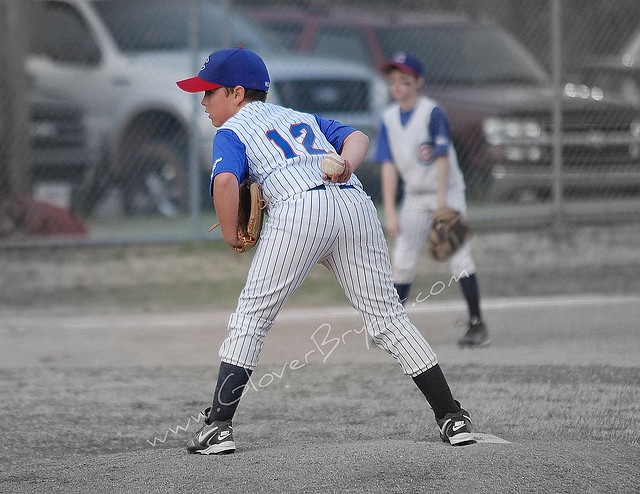Describe the objects in this image and their specific colors. I can see people in gray, lightgray, darkgray, and black tones, car in gray and darkgray tones, car in gray, black, and darkblue tones, people in gray, darkgray, and lightgray tones, and car in gray and black tones in this image. 